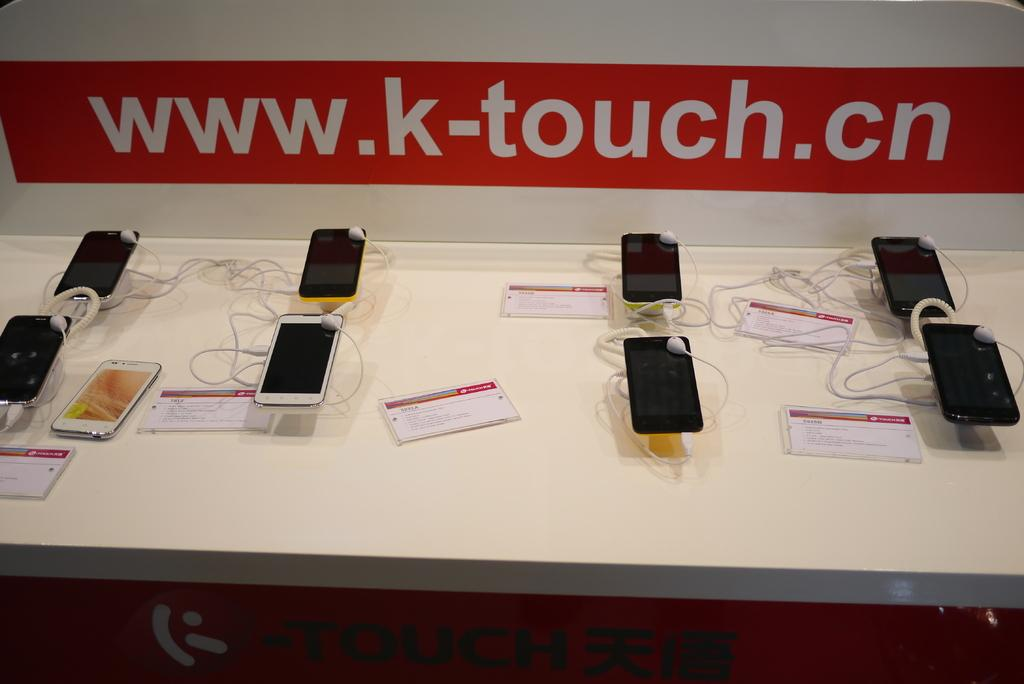<image>
Offer a succinct explanation of the picture presented. A display has cell phones and a sign for www.k-touch.cn. 